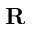<formula> <loc_0><loc_0><loc_500><loc_500>{ R }</formula> 